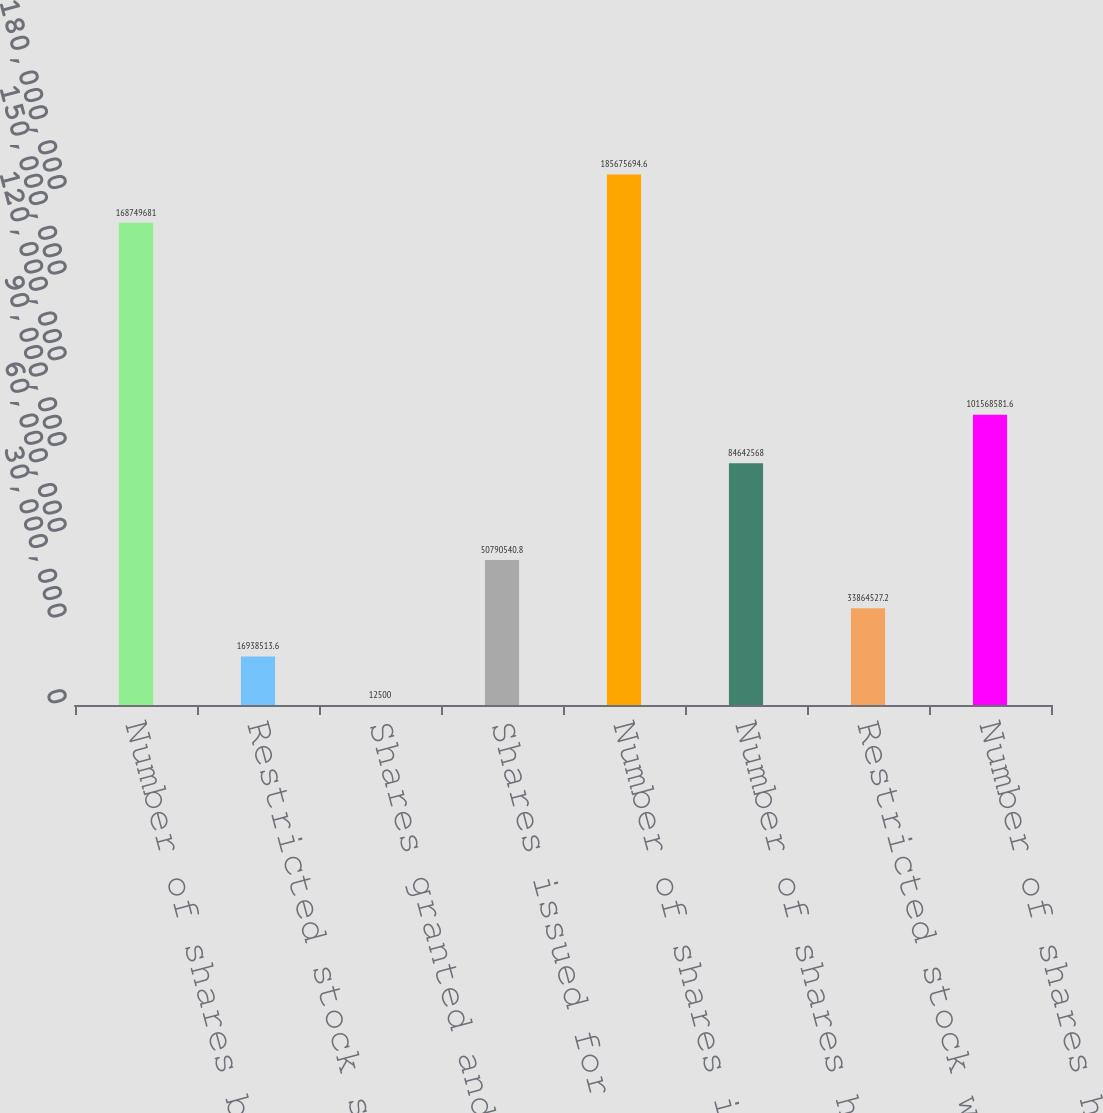Convert chart to OTSL. <chart><loc_0><loc_0><loc_500><loc_500><bar_chart><fcel>Number of shares beginning of<fcel>Restricted stock shares issued<fcel>Shares granted and issued<fcel>Shares issued for vested<fcel>Number of shares issued end of<fcel>Number of shares held<fcel>Restricted stock withheld or<fcel>Number of shares held end of<nl><fcel>1.6875e+08<fcel>1.69385e+07<fcel>12500<fcel>5.07905e+07<fcel>1.85676e+08<fcel>8.46426e+07<fcel>3.38645e+07<fcel>1.01569e+08<nl></chart> 